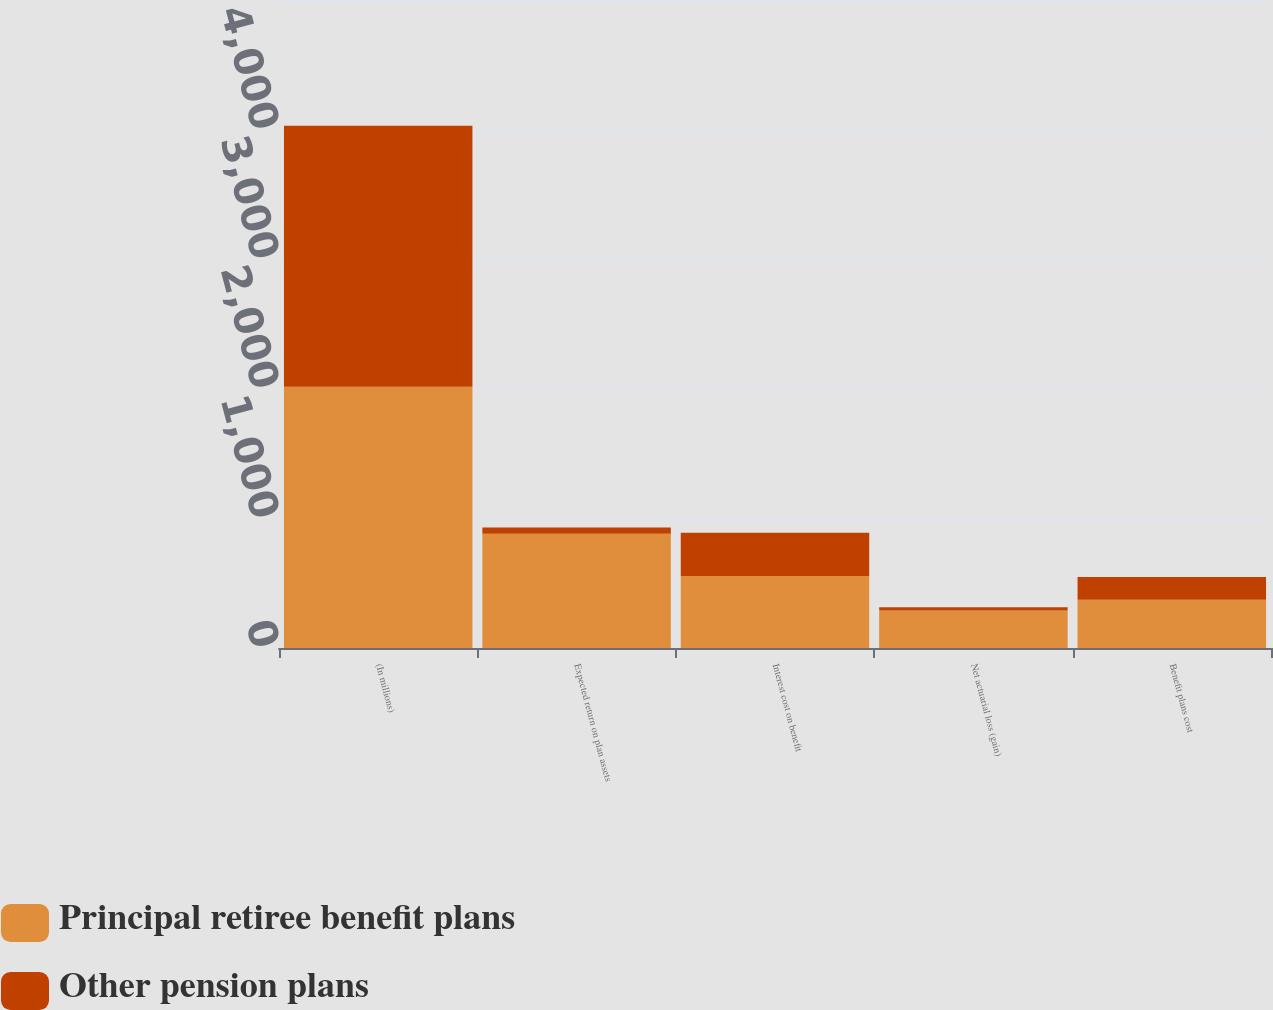Convert chart. <chart><loc_0><loc_0><loc_500><loc_500><stacked_bar_chart><ecel><fcel>(In millions)<fcel>Expected return on plan assets<fcel>Interest cost on benefit<fcel>Net actuarial loss (gain)<fcel>Benefit plans cost<nl><fcel>Principal retiree benefit plans<fcel>2015<fcel>881<fcel>555<fcel>289<fcel>373<nl><fcel>Other pension plans<fcel>2015<fcel>48<fcel>335<fcel>25<fcel>174<nl></chart> 